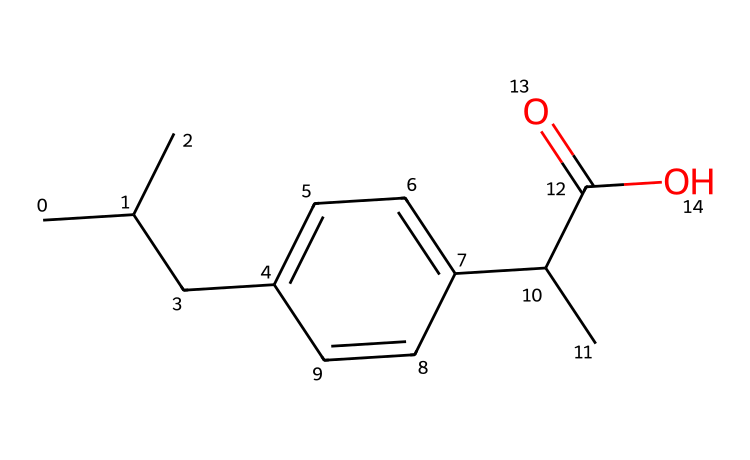How many carbon atoms are in this structure? By examining the SMILES representation, each 'C' represents a carbon atom. Counting them gives a total of 15 carbon atoms.
Answer: 15 What functional group is present in this chemical? The 'C(=O)O' portion indicates a carboxylic acid functional group, characterized by the presence of a carbonyl (C=O) and a hydroxyl (–OH) group.
Answer: carboxylic acid What type of drug is ibuprofen classified as? Ibuprofen is classified as a nonsteroidal anti-inflammatory drug (NSAID), designed to alleviate pain, reduce inflammation, and lower fever.
Answer: nonsteroidal anti-inflammatory drug How many rings are present in this molecular structure? In the structure denoted by the SMILES, there are no cyclic components indicated; thus, there are zero rings present in this molecule.
Answer: 0 What role does ibuprofen play in the body? Ibuprofen reduces inflammation by inhibiting the enzymes cyclooxygenase (COX-1 and COX-2), leading to decreased production of prostaglandins, which are mediators of inflammation and pain.
Answer: reduces inflammation What is the molecular weight of ibuprofen? To find the molecular weight, you sum the atomic weights of each atom in the molecular formula. The calculated molecular weight for ibuprofen comes out to approximately 206.29 g/mol.
Answer: 206.29 g/mol Is ibuprofen more soluble in water or organic solvents? Ibuprofen is generally more soluble in organic solvents due to its hydrophobic alkyl groups and lesser polarity compared to hydrophilic solvents.
Answer: organic solvents 